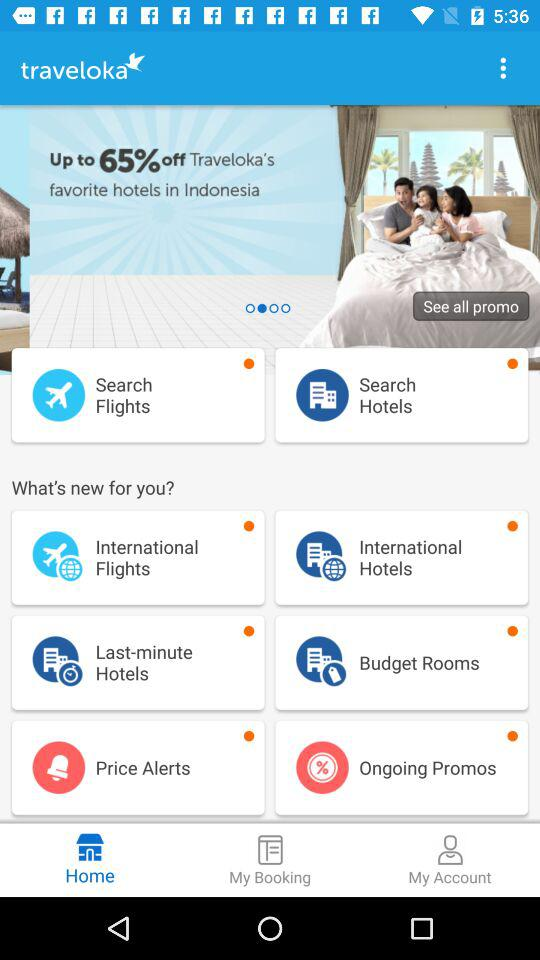Which tab has been selected? The selected tab is "Home". 